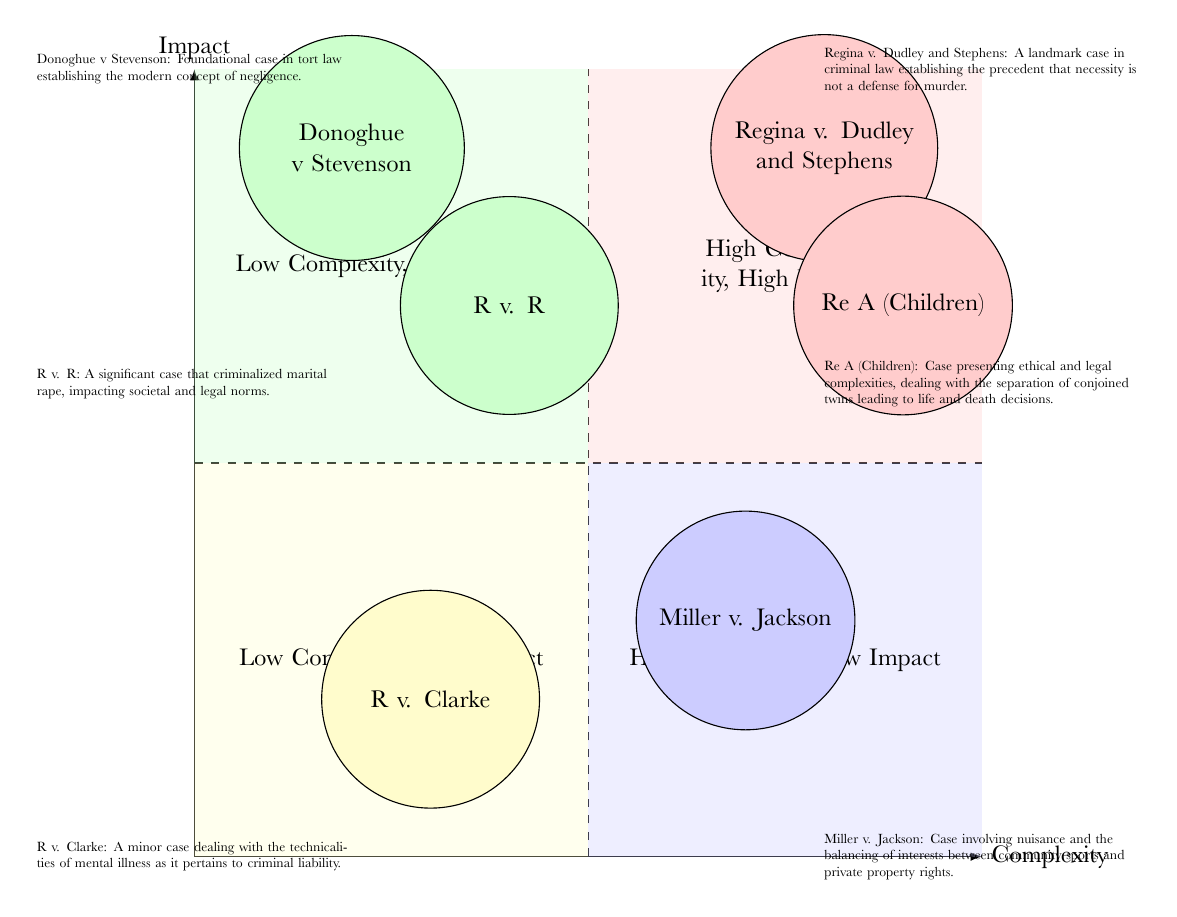What case is located in the High Complexity, High Impact quadrant? The case "Regina v. Dudley and Stephens" is positioned within the High Complexity, High Impact quadrant, as shown by its location in the upper right section of the diagram.
Answer: Regina v. Dudley and Stephens How many cases are in the Low Complexity, High Impact quadrant? There are two cases, "Donoghue v Stevenson" and "R v. R", represented in the Low Complexity, High Impact quadrant, demonstrated by the count of nodes in that specific area of the diagram.
Answer: 2 What is the primary legal issue in the case "Miller v. Jackson"? The case "Miller v. Jackson" addresses nuisance and the balancing of interests, as indicated in its description which provides context about the legal complexities involved.
Answer: Nuisance Which quadrant contains a single case? The quadrant labelled "High Complexity, Low Impact" contains only the case "Miller v. Jackson," making it the only such quadrant with a single case representation.
Answer: High Complexity, Low Impact What does the case "R v. Clarke" involve? The case "R v. Clarke" deals with technicalities of mental illness related to criminal liability, as stated in its description, highlighting its specific legal focus.
Answer: Mental illness Which case from the Low Complexity, High Impact quadrant impacted societal norms? "R v. R" is the case that criminalized marital rape, thereby having a significant impact on societal and legal norms, making it a notable example from that quadrant.
Answer: R v. R How are cases distinguished in the High Complexity, High Impact quadrant? The cases in this quadrant are distinguished by their significant legal implications and complex legal reasoning, represented by "Regina v. Dudley and Stephens" and "Re A (Children)", both of which have profound impacts on legal precedents.
Answer: Significant legal implications What is the primary focus of legal discussions in "Re A (Children)"? The primary focus of legal discussions in "Re A (Children)" revolves around ethical and life-and-death decisions regarding the separation of conjoined twins, demonstrating the complex legal ethics involved in this landmark case.
Answer: Ethical decisions 